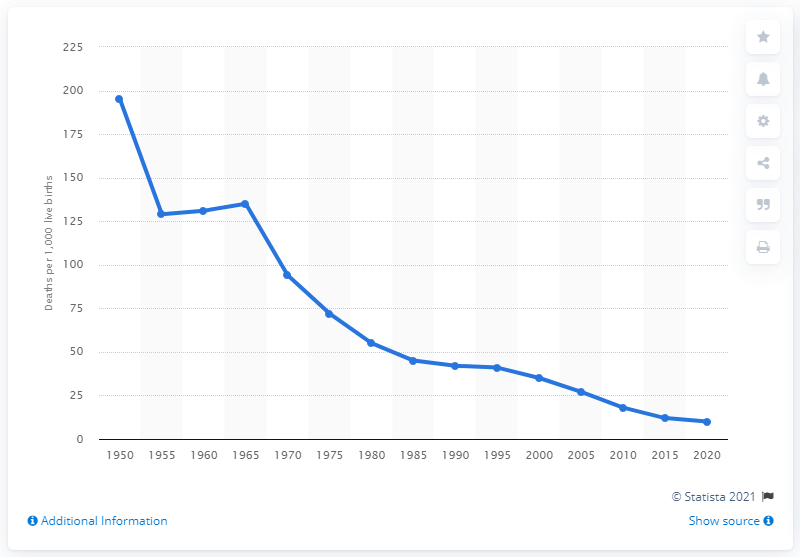Point out several critical features in this image. The infant mortality rate in China was approximately 211 per 1,000 live births in 1950. 